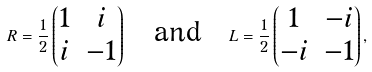Convert formula to latex. <formula><loc_0><loc_0><loc_500><loc_500>R = \frac { 1 } { 2 } \begin{pmatrix} 1 & i \\ i & - 1 \end{pmatrix} \quad \text {and} \quad L = \frac { 1 } { 2 } \begin{pmatrix} 1 & - i \\ - i & - 1 \end{pmatrix} ,</formula> 